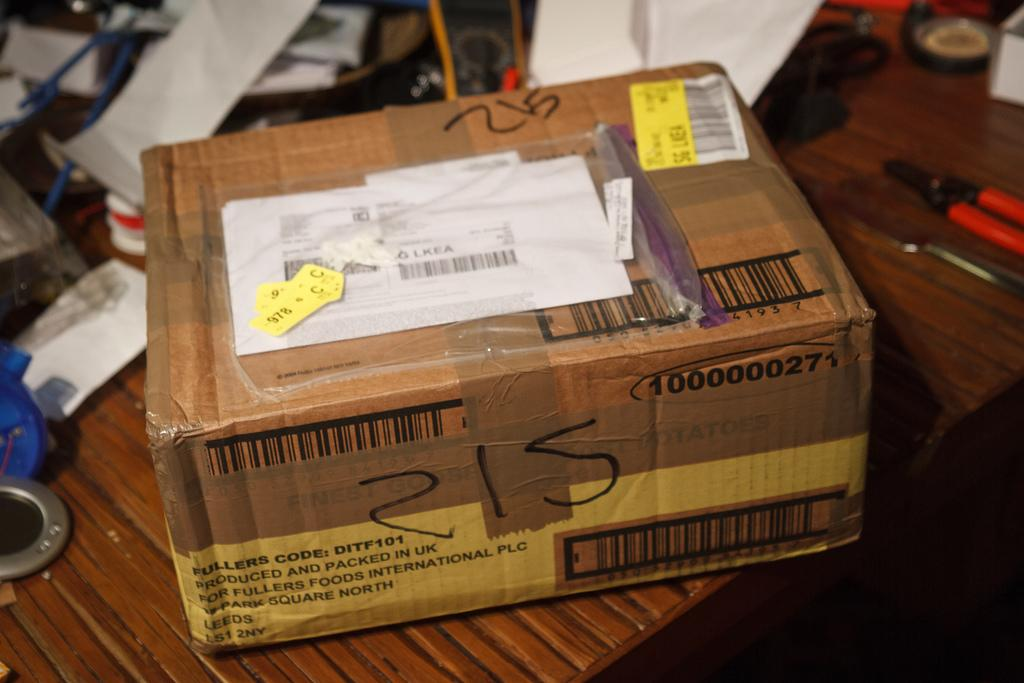<image>
Provide a brief description of the given image. Box with the number 215 on the front on top of a table. 